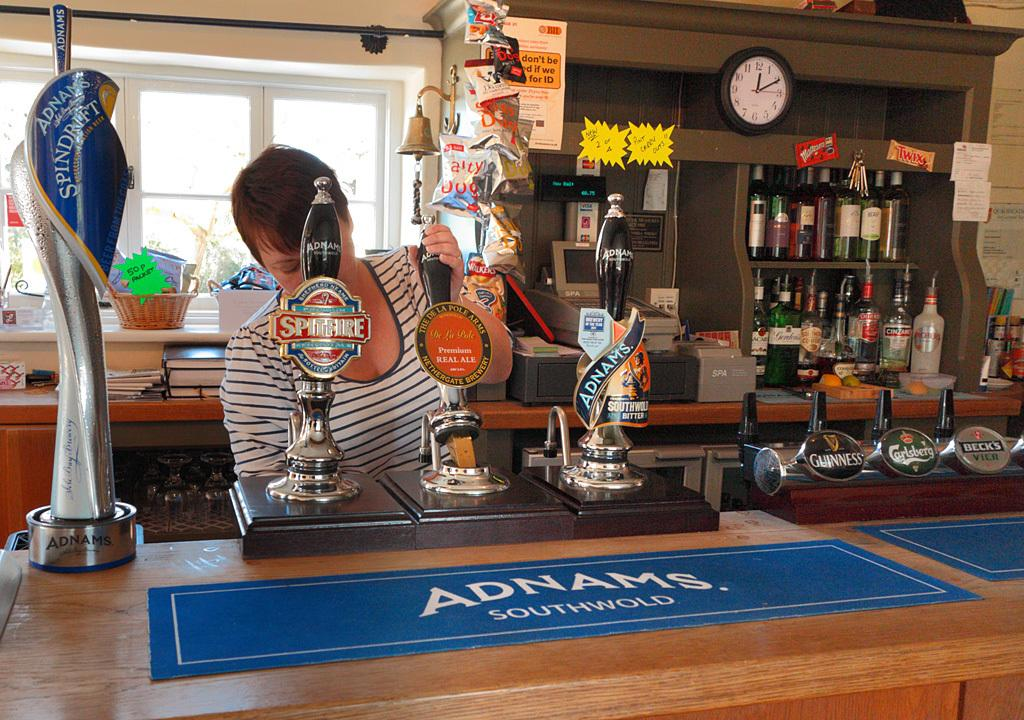<image>
Describe the image concisely. Adnam's, Guinness, Spitfire, and Carlsberg are among the draft beers available at this bar. 